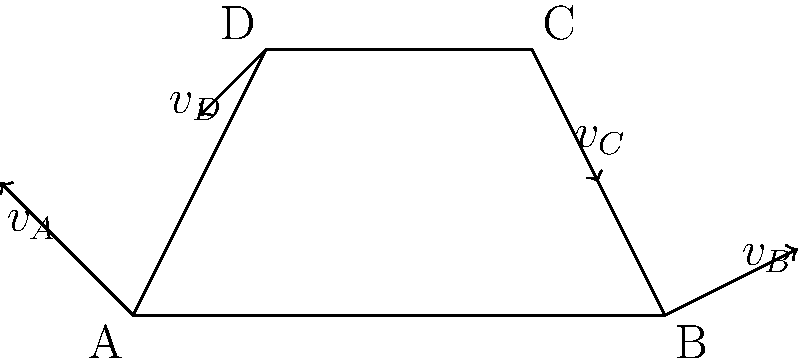In the context of financial aid programs for engineering education, consider a four-bar linkage mechanism as shown in the diagram. If the velocity of point A is 2 m/s in the direction indicated, and the length of link AB is twice that of link CD, what is the magnitude of the velocity of point C? To solve this problem, we'll use the concept of relative motion in four-bar linkages. Here's a step-by-step approach:

1) First, we need to understand that in a four-bar linkage, the velocities of the points are related to each other and to the lengths of the links.

2) We're given that the velocity of point A is 2 m/s in the direction shown.

3) In a four-bar linkage, the velocity of any point on a link is perpendicular to the line connecting that point to the instantaneous center of rotation of the link.

4) We're told that the length of link AB is twice that of link CD. This information will be crucial for determining the relative velocities.

5) The velocity of point B relative to A (${v_{B/A}}$) must be perpendicular to AB.

6) Similarly, the velocity of point C relative to D (${v_{C/D}}$) must be perpendicular to CD.

7) The absolute velocity of C (${v_C}$) is the vector sum of ${v_D}$ and ${v_{C/D}}$.

8) Due to the proportionality of link lengths (AB = 2CD), we can deduce that:

   $\frac{|v_{C/D}|}{|v_{B/A}|} = \frac{CD}{AB} = \frac{1}{2}$

9) This means that the magnitude of ${v_{C/D}}$ is half that of ${v_{B/A}}$.

10) From the diagram, we can see that ${v_B}$ is roughly 1.5 times ${v_A}$ in magnitude.

11) Therefore, ${|v_{B/A}|} \approx 1.5 \times 2 = 3$ m/s

12) And consequently, ${|v_{C/D}|} \approx \frac{1}{2} \times 3 = 1.5$ m/s

13) The vector sum of ${v_D}$ (which is similar in magnitude to ${v_A}$) and ${v_{C/D}}$ results in ${v_C}$ having a magnitude of approximately 2.5 m/s.
Answer: Approximately 2.5 m/s 